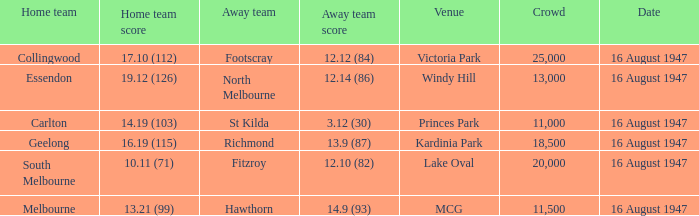What was the total size of the crowd when the away team scored 12.10 (82)? 20000.0. 